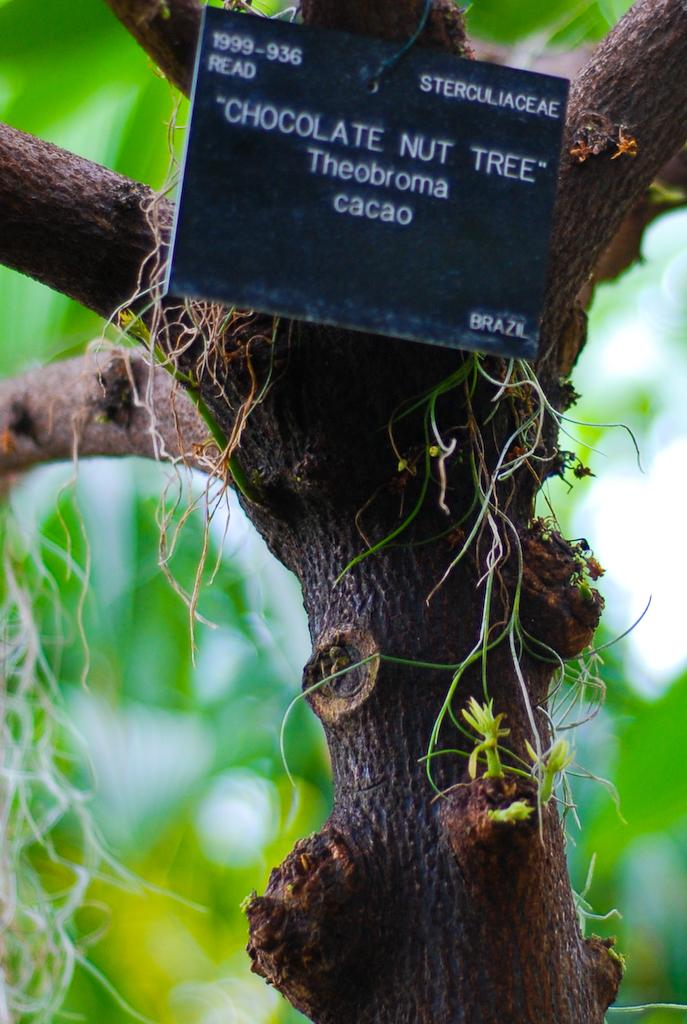Where was the image taken? The image was taken outdoors. What can be seen in the background of the image? There is a tree with green leaves in the background. What is in the middle of the image? There is a tree and a board with text on it in the middle of the image. How many children are playing near the tree in the image? There are no children present in the image; it only features a tree and a board with text. 